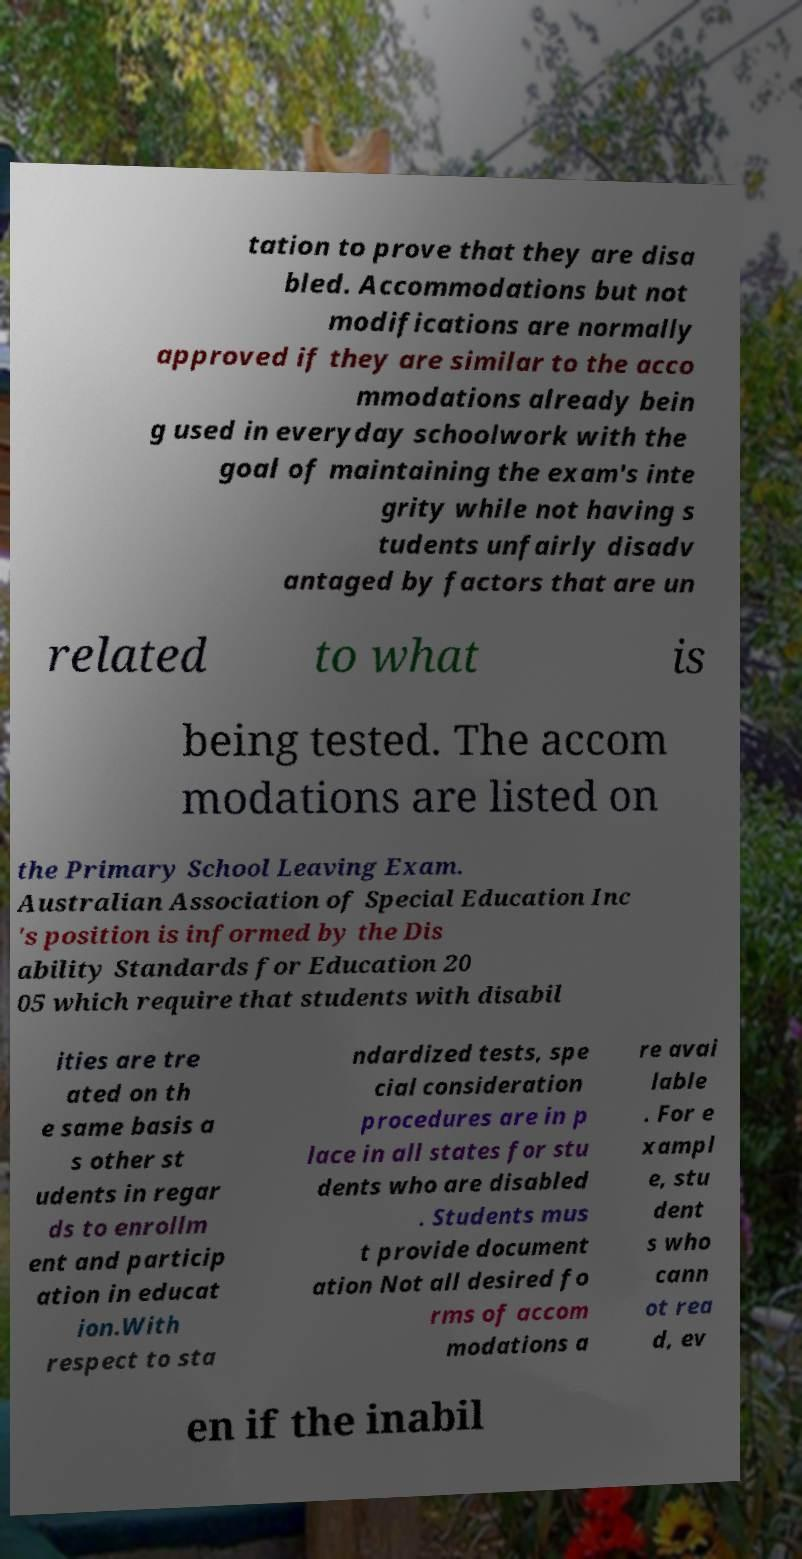There's text embedded in this image that I need extracted. Can you transcribe it verbatim? tation to prove that they are disa bled. Accommodations but not modifications are normally approved if they are similar to the acco mmodations already bein g used in everyday schoolwork with the goal of maintaining the exam's inte grity while not having s tudents unfairly disadv antaged by factors that are un related to what is being tested. The accom modations are listed on the Primary School Leaving Exam. Australian Association of Special Education Inc 's position is informed by the Dis ability Standards for Education 20 05 which require that students with disabil ities are tre ated on th e same basis a s other st udents in regar ds to enrollm ent and particip ation in educat ion.With respect to sta ndardized tests, spe cial consideration procedures are in p lace in all states for stu dents who are disabled . Students mus t provide document ation Not all desired fo rms of accom modations a re avai lable . For e xampl e, stu dent s who cann ot rea d, ev en if the inabil 